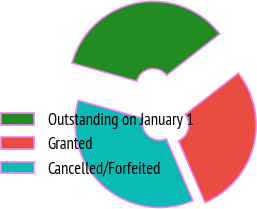Convert chart to OTSL. <chart><loc_0><loc_0><loc_500><loc_500><pie_chart><fcel>Outstanding on January 1<fcel>Granted<fcel>Cancelled/Forfeited<nl><fcel>35.13%<fcel>29.07%<fcel>35.8%<nl></chart> 